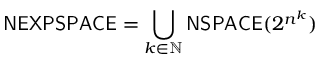<formula> <loc_0><loc_0><loc_500><loc_500>{ N E X P S P A C E } = \bigcup _ { k \in \mathbb { N } } { N S P A C E } ( 2 ^ { n ^ { k } } )</formula> 